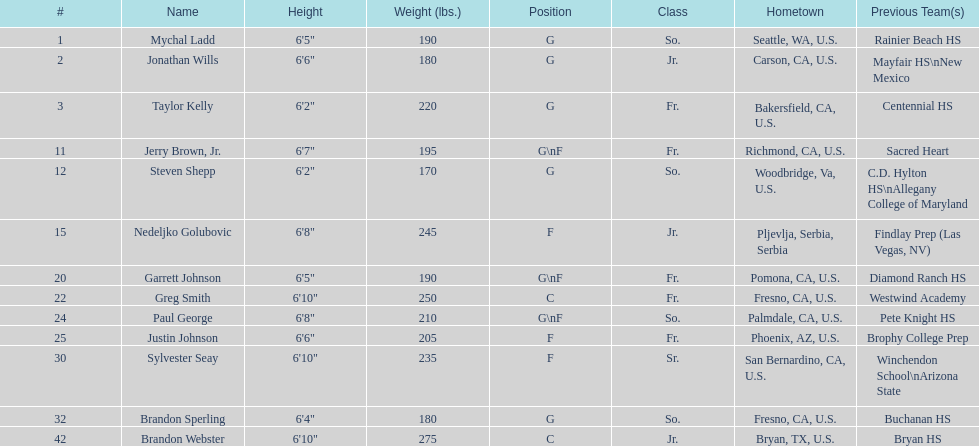Who is the next heaviest player after nedelijko golubovic? Sylvester Seay. 